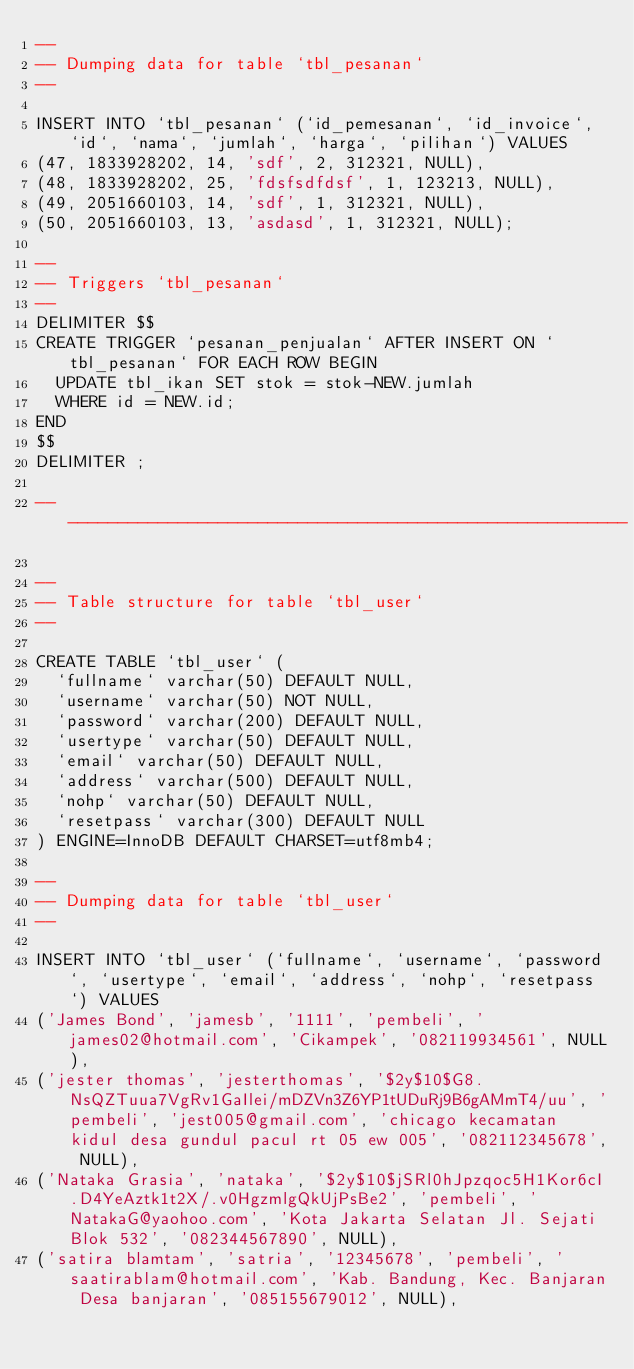<code> <loc_0><loc_0><loc_500><loc_500><_SQL_>--
-- Dumping data for table `tbl_pesanan`
--

INSERT INTO `tbl_pesanan` (`id_pemesanan`, `id_invoice`, `id`, `nama`, `jumlah`, `harga`, `pilihan`) VALUES
(47, 1833928202, 14, 'sdf', 2, 312321, NULL),
(48, 1833928202, 25, 'fdsfsdfdsf', 1, 123213, NULL),
(49, 2051660103, 14, 'sdf', 1, 312321, NULL),
(50, 2051660103, 13, 'asdasd', 1, 312321, NULL);

--
-- Triggers `tbl_pesanan`
--
DELIMITER $$
CREATE TRIGGER `pesanan_penjualan` AFTER INSERT ON `tbl_pesanan` FOR EACH ROW BEGIN
	UPDATE tbl_ikan SET stok = stok-NEW.jumlah
	WHERE id = NEW.id;
END
$$
DELIMITER ;

-- --------------------------------------------------------

--
-- Table structure for table `tbl_user`
--

CREATE TABLE `tbl_user` (
  `fullname` varchar(50) DEFAULT NULL,
  `username` varchar(50) NOT NULL,
  `password` varchar(200) DEFAULT NULL,
  `usertype` varchar(50) DEFAULT NULL,
  `email` varchar(50) DEFAULT NULL,
  `address` varchar(500) DEFAULT NULL,
  `nohp` varchar(50) DEFAULT NULL,
  `resetpass` varchar(300) DEFAULT NULL
) ENGINE=InnoDB DEFAULT CHARSET=utf8mb4;

--
-- Dumping data for table `tbl_user`
--

INSERT INTO `tbl_user` (`fullname`, `username`, `password`, `usertype`, `email`, `address`, `nohp`, `resetpass`) VALUES
('James Bond', 'jamesb', '1111', 'pembeli', 'james02@hotmail.com', 'Cikampek', '082119934561', NULL),
('jester thomas', 'jesterthomas', '$2y$10$G8.NsQZTuua7VgRv1GaIlei/mDZVn3Z6YP1tUDuRj9B6gAMmT4/uu', 'pembeli', 'jest005@gmail.com', 'chicago kecamatan kidul desa gundul pacul rt 05 ew 005', '082112345678', NULL),
('Nataka Grasia', 'nataka', '$2y$10$jSRl0hJpzqoc5H1Kor6cI.D4YeAztk1t2X/.v0HgzmlgQkUjPsBe2', 'pembeli', 'NatakaG@yaohoo.com', 'Kota Jakarta Selatan Jl. Sejati Blok 532', '082344567890', NULL),
('satira blamtam', 'satria', '12345678', 'pembeli', 'saatirablam@hotmail.com', 'Kab. Bandung, Kec. Banjaran Desa banjaran', '085155679012', NULL),</code> 